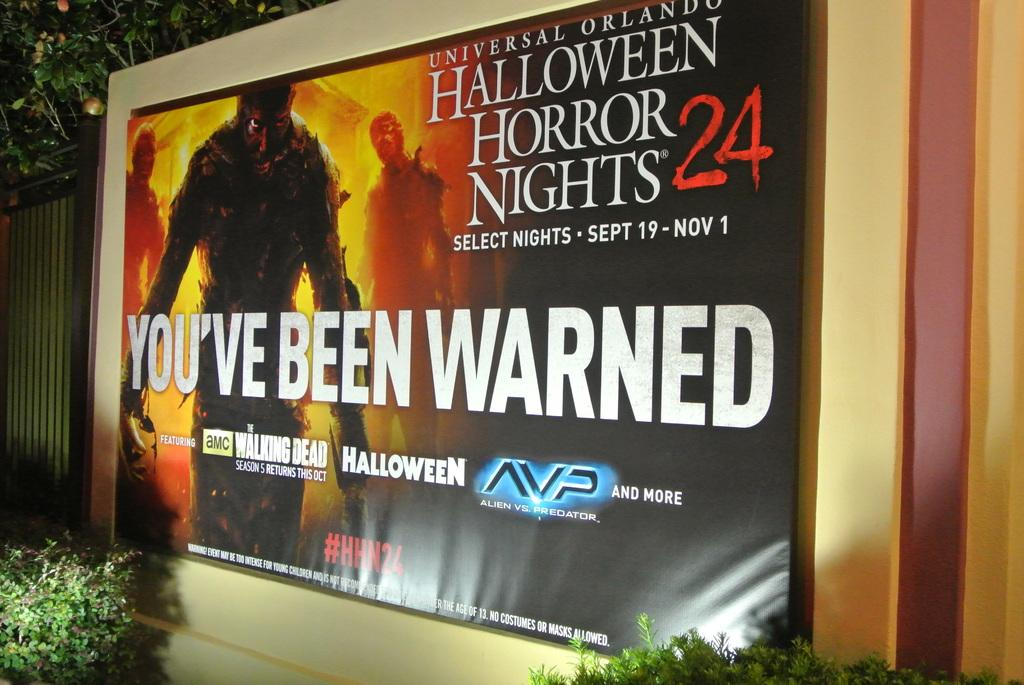Provide a one-sentence caption for the provided image. Halloween Horror Nights 24 selected nights from September through November sign with You've Been Warned in large white letters. 